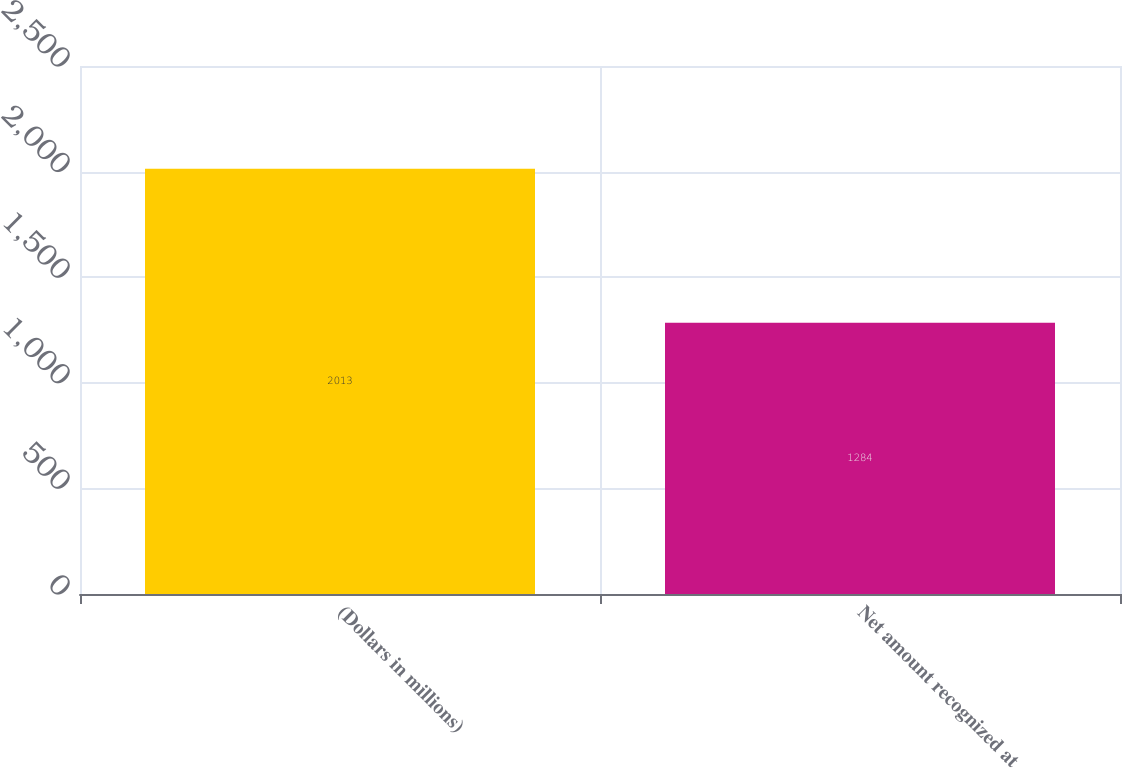Convert chart. <chart><loc_0><loc_0><loc_500><loc_500><bar_chart><fcel>(Dollars in millions)<fcel>Net amount recognized at<nl><fcel>2013<fcel>1284<nl></chart> 